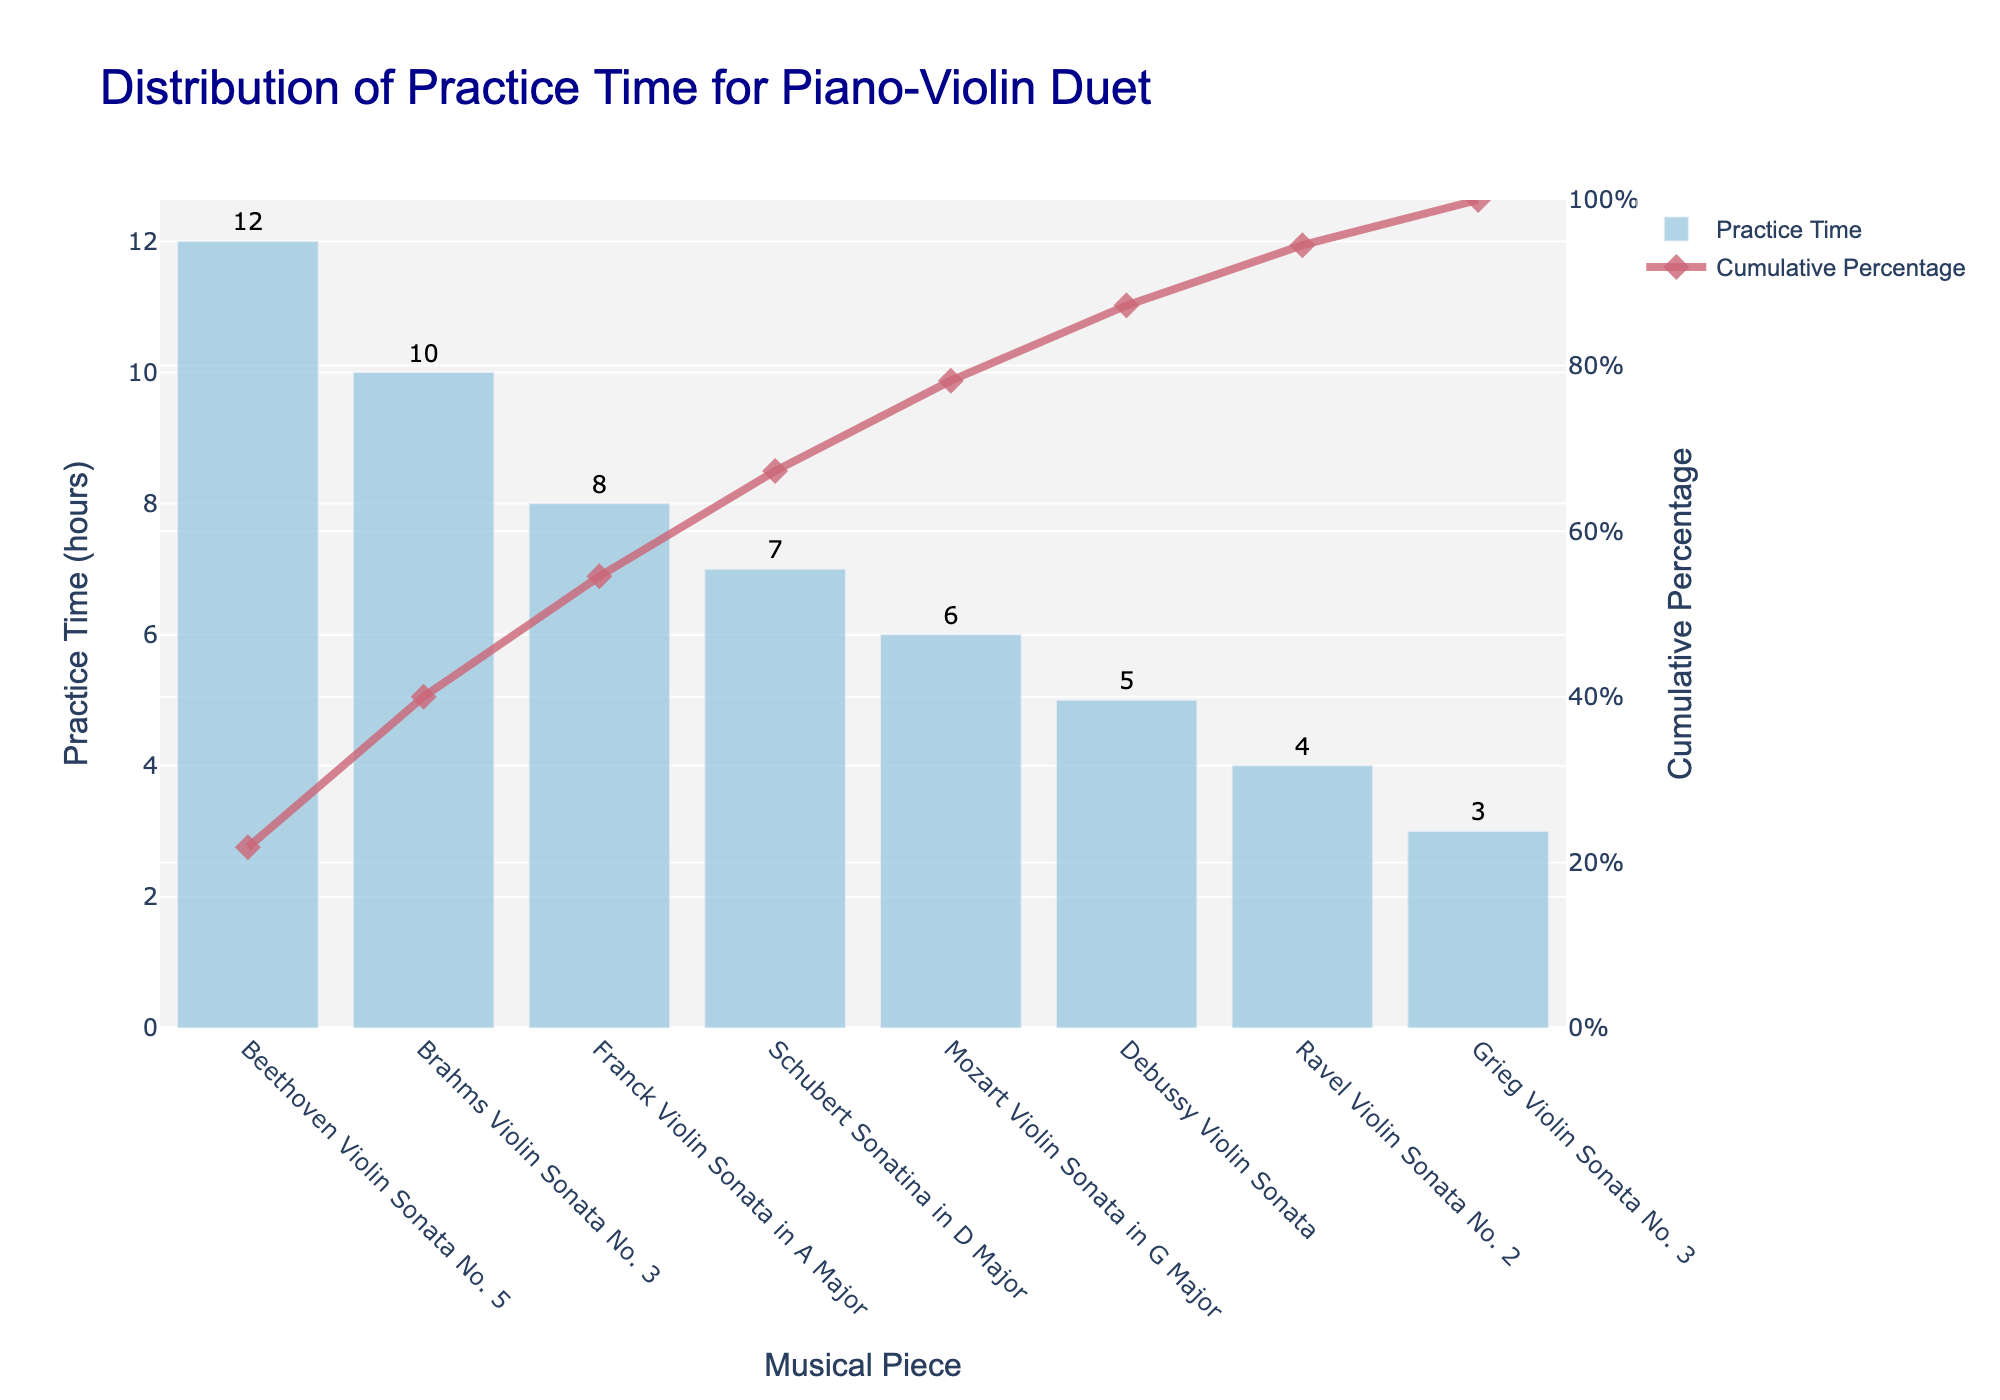What is the title of the figure? The title of the figure is displayed at the top in larger, bold text, typically providing an overview of the data being visualized. The title of this figure should be located at the top and is "Distribution of Practice Time for Piano-Violin Duet".
Answer: Distribution of Practice Time for Piano-Violin Duet How many musical pieces are represented in the chart? Count the number of unique items on the x-axis of the bar chart. There are eight musical pieces listed: "Beethoven Violin Sonata No. 5", "Brahms Violin Sonata No. 3", "Franck Violin Sonata in A Major", "Schubert Sonatina in D Major", "Mozart Violin Sonata in G Major", "Debussy Violin Sonata", "Ravel Violin Sonata No. 2", and "Grieg Violin Sonata No. 3".
Answer: 8 Which musical piece has the highest practice time? Look at the height of the bars in the bar chart and identify the tallest one. The tallest bar represents "Beethoven Violin Sonata No. 5".
Answer: Beethoven Violin Sonata No. 5 What is the cumulative percentage of practice time after practicing "Franck Violin Sonata in A Major"? Identify the point that corresponds to "Franck Violin Sonata in A Major" on the cumulative percentage line and read the value on the right y-axis. The cumulative percentage at that point is around 62.50%.
Answer: 62.50% What is the total practice time for "Brahms Violin Sonata No. 3" and "Debussy Violin Sonata"? Add the practice times for "Brahms Violin Sonata No. 3" and "Debussy Violin Sonata". The times are 10 hours and 5 hours respectively. Therefore, 10 + 5 = 15 hours.
Answer: 15 hours Which musical piece contributed to passing the 50% cumulative percentage mark? Look at the cumulative percentage line and identify the first musical piece after which the cumulative percentage exceeds 50%. The first piece that does this is "Franck Violin Sonata in A Major".
Answer: Franck Violin Sonata in A Major How much more practice time is spent on "Beethoven Violin Sonata No. 5" compared to "Grieg Violin Sonata No. 3"? Subtract the practice time of "Grieg Violin Sonata No. 3" from that of "Beethoven Violin Sonata No. 5". "Beethoven Violin Sonata No. 5" has 12 hours and "Grieg Violin Sonata No. 3" has 3 hours. So, 12 - 3 = 9 hours more is spent on "Beethoven Violin Sonata No. 5".
Answer: 9 hours What is the cumulative percentage after practicing the first three pieces? Sum the practice time of the first three pieces, then divide by the total practice time and multiply by 100 to find the cumulative percentage. The pieces are "Beethoven Violin Sonata No. 5" (12 hours), "Brahms Violin Sonata No. 3" (10 hours), and "Franck Violin Sonata in A Major" (8 hours). The total is 12+10+8 = 30 hours. The total practice time is 55 hours. Therefore, (30/55)*100 = 54.55%.
Answer: 54.55% Which musical piece contributes the least to the total practice time? Identify the shortest bar in the bar chart. The shortest bar represents "Grieg Violin Sonata No. 3".
Answer: Grieg Violin Sonata No. 3 